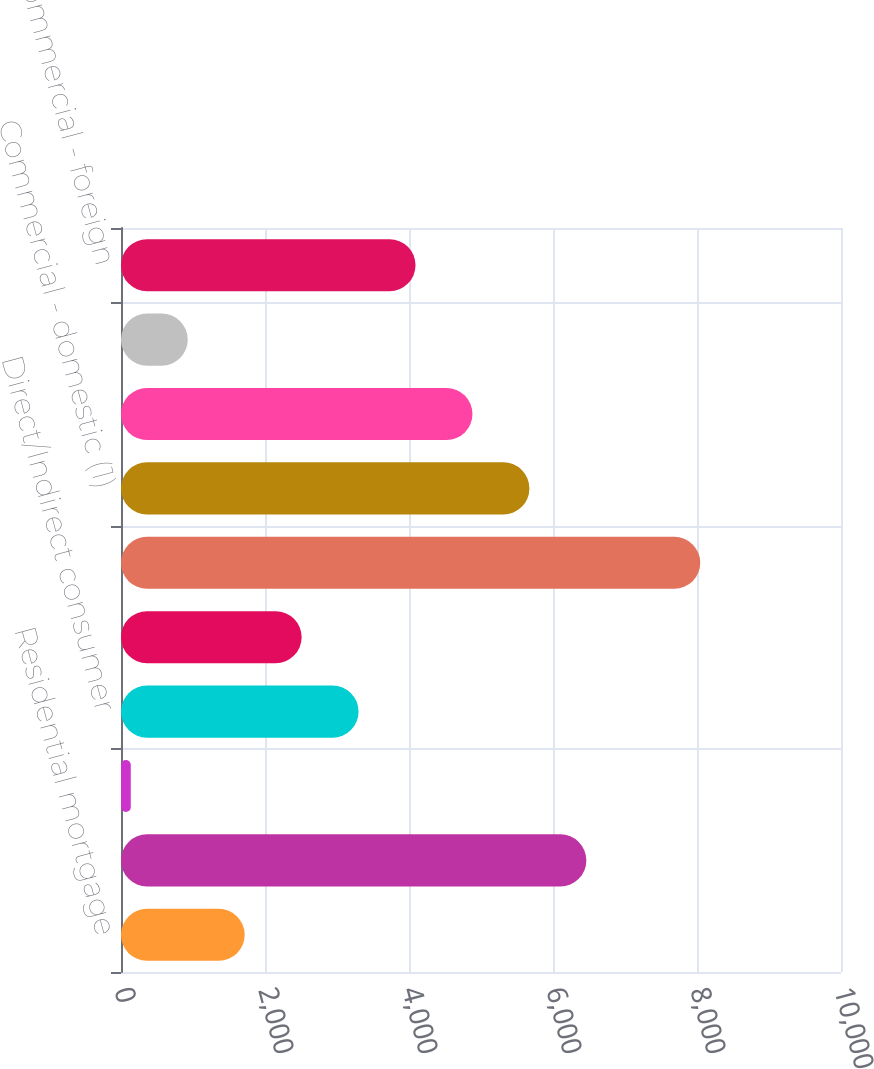<chart> <loc_0><loc_0><loc_500><loc_500><bar_chart><fcel>Residential mortgage<fcel>Credit card - domestic<fcel>Home equity<fcel>Direct/Indirect consumer<fcel>Other consumer<fcel>Total consumer<fcel>Commercial - domestic (1)<fcel>Commercial real estate<fcel>Commercial lease financing<fcel>Commercial - foreign<nl><fcel>1717.8<fcel>6463.2<fcel>136<fcel>3299.6<fcel>2508.7<fcel>8045<fcel>5672.3<fcel>4881.4<fcel>926.9<fcel>4090.5<nl></chart> 